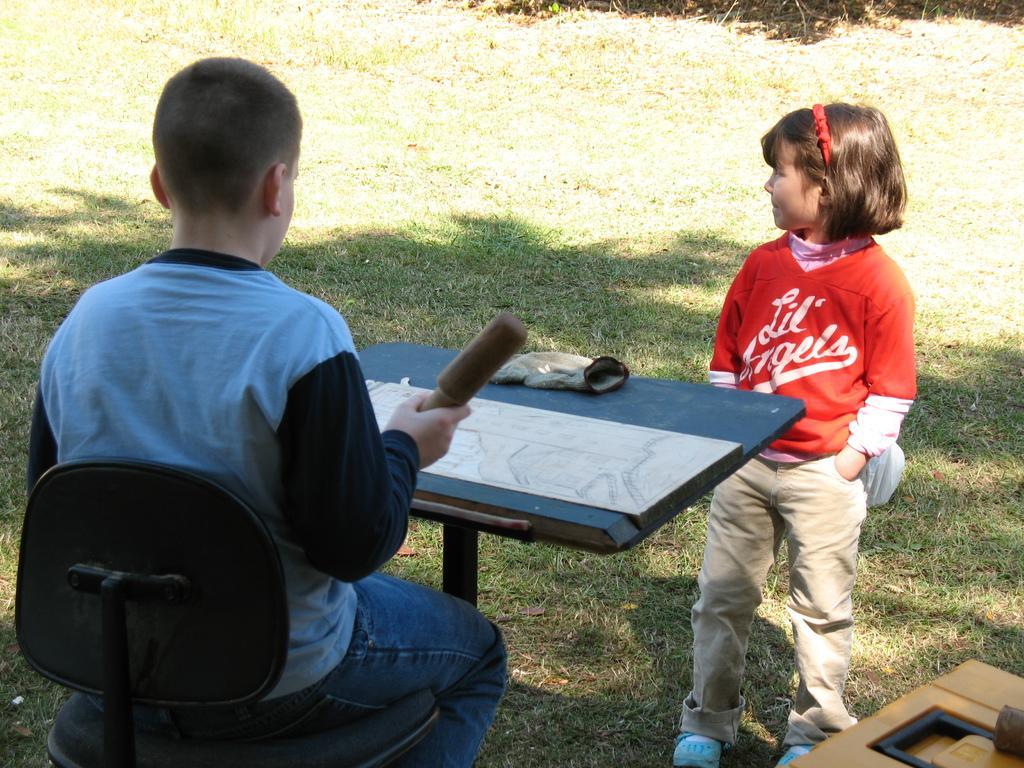How would you summarize this image in a sentence or two? It seems to be the image is inside a garden. In the image on right side there is a kid standing in front of a table. On left side we can see a boy sitting in front of a table, on table we can see a chart and a gloves at bottom there is a grass. 